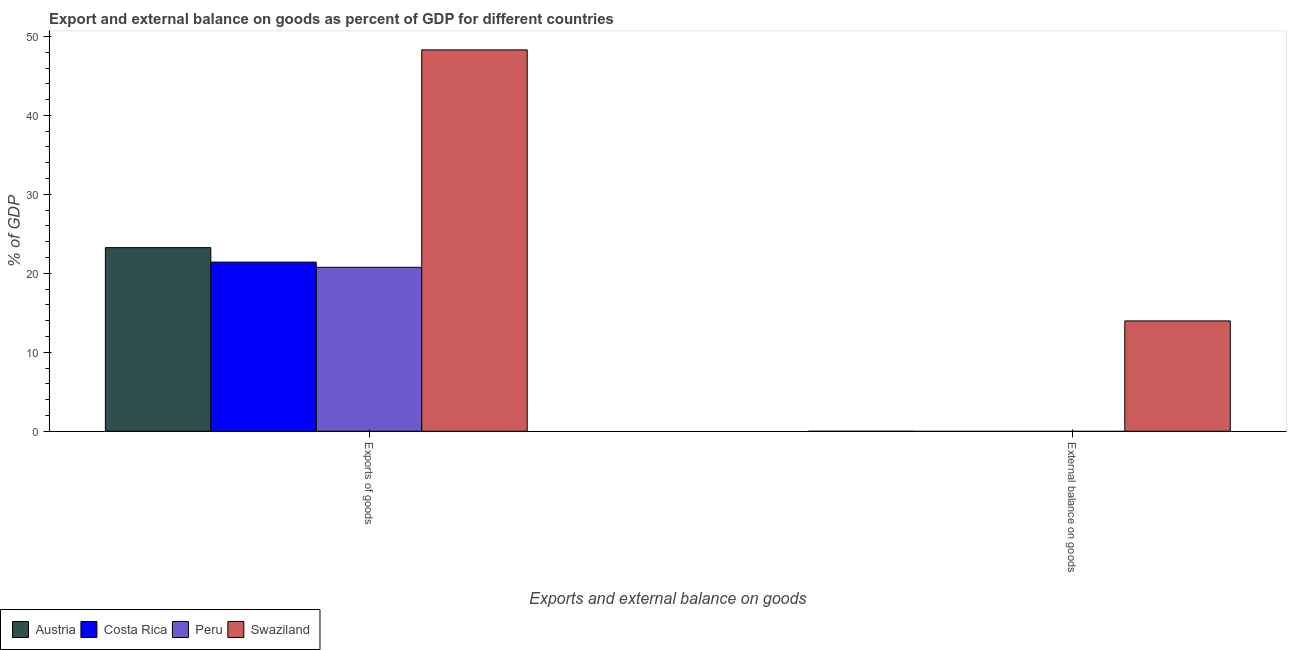Are the number of bars per tick equal to the number of legend labels?
Offer a very short reply. No. How many bars are there on the 1st tick from the right?
Your answer should be compact. 1. What is the label of the 2nd group of bars from the left?
Offer a terse response. External balance on goods. What is the export of goods as percentage of gdp in Swaziland?
Your answer should be compact. 48.29. Across all countries, what is the maximum external balance on goods as percentage of gdp?
Your answer should be compact. 13.97. Across all countries, what is the minimum export of goods as percentage of gdp?
Ensure brevity in your answer.  20.76. In which country was the export of goods as percentage of gdp maximum?
Keep it short and to the point. Swaziland. What is the total export of goods as percentage of gdp in the graph?
Ensure brevity in your answer.  113.72. What is the difference between the export of goods as percentage of gdp in Austria and that in Peru?
Offer a very short reply. 2.49. What is the difference between the export of goods as percentage of gdp in Swaziland and the external balance on goods as percentage of gdp in Austria?
Offer a very short reply. 48.29. What is the average export of goods as percentage of gdp per country?
Make the answer very short. 28.43. What is the ratio of the export of goods as percentage of gdp in Austria to that in Costa Rica?
Ensure brevity in your answer.  1.09. Are all the bars in the graph horizontal?
Offer a very short reply. No. How many countries are there in the graph?
Offer a very short reply. 4. Are the values on the major ticks of Y-axis written in scientific E-notation?
Provide a short and direct response. No. Does the graph contain any zero values?
Offer a very short reply. Yes. Where does the legend appear in the graph?
Provide a short and direct response. Bottom left. How many legend labels are there?
Make the answer very short. 4. How are the legend labels stacked?
Give a very brief answer. Horizontal. What is the title of the graph?
Your response must be concise. Export and external balance on goods as percent of GDP for different countries. What is the label or title of the X-axis?
Make the answer very short. Exports and external balance on goods. What is the label or title of the Y-axis?
Your answer should be very brief. % of GDP. What is the % of GDP in Austria in Exports of goods?
Provide a succinct answer. 23.25. What is the % of GDP in Costa Rica in Exports of goods?
Offer a very short reply. 21.42. What is the % of GDP in Peru in Exports of goods?
Offer a terse response. 20.76. What is the % of GDP of Swaziland in Exports of goods?
Your answer should be very brief. 48.29. What is the % of GDP in Costa Rica in External balance on goods?
Give a very brief answer. 0. What is the % of GDP of Peru in External balance on goods?
Your response must be concise. 0. What is the % of GDP of Swaziland in External balance on goods?
Keep it short and to the point. 13.97. Across all Exports and external balance on goods, what is the maximum % of GDP in Austria?
Offer a terse response. 23.25. Across all Exports and external balance on goods, what is the maximum % of GDP in Costa Rica?
Your response must be concise. 21.42. Across all Exports and external balance on goods, what is the maximum % of GDP of Peru?
Ensure brevity in your answer.  20.76. Across all Exports and external balance on goods, what is the maximum % of GDP in Swaziland?
Offer a terse response. 48.29. Across all Exports and external balance on goods, what is the minimum % of GDP of Austria?
Offer a terse response. 0. Across all Exports and external balance on goods, what is the minimum % of GDP of Costa Rica?
Provide a short and direct response. 0. Across all Exports and external balance on goods, what is the minimum % of GDP in Swaziland?
Provide a short and direct response. 13.97. What is the total % of GDP in Austria in the graph?
Make the answer very short. 23.25. What is the total % of GDP in Costa Rica in the graph?
Give a very brief answer. 21.42. What is the total % of GDP of Peru in the graph?
Offer a terse response. 20.76. What is the total % of GDP of Swaziland in the graph?
Your answer should be compact. 62.26. What is the difference between the % of GDP of Swaziland in Exports of goods and that in External balance on goods?
Your answer should be compact. 34.32. What is the difference between the % of GDP in Austria in Exports of goods and the % of GDP in Swaziland in External balance on goods?
Your answer should be compact. 9.28. What is the difference between the % of GDP of Costa Rica in Exports of goods and the % of GDP of Swaziland in External balance on goods?
Your answer should be compact. 7.45. What is the difference between the % of GDP in Peru in Exports of goods and the % of GDP in Swaziland in External balance on goods?
Your answer should be very brief. 6.79. What is the average % of GDP in Austria per Exports and external balance on goods?
Your answer should be compact. 11.62. What is the average % of GDP in Costa Rica per Exports and external balance on goods?
Your answer should be compact. 10.71. What is the average % of GDP of Peru per Exports and external balance on goods?
Keep it short and to the point. 10.38. What is the average % of GDP of Swaziland per Exports and external balance on goods?
Provide a short and direct response. 31.13. What is the difference between the % of GDP in Austria and % of GDP in Costa Rica in Exports of goods?
Your answer should be compact. 1.83. What is the difference between the % of GDP of Austria and % of GDP of Peru in Exports of goods?
Make the answer very short. 2.49. What is the difference between the % of GDP in Austria and % of GDP in Swaziland in Exports of goods?
Provide a succinct answer. -25.05. What is the difference between the % of GDP of Costa Rica and % of GDP of Peru in Exports of goods?
Provide a short and direct response. 0.65. What is the difference between the % of GDP in Costa Rica and % of GDP in Swaziland in Exports of goods?
Keep it short and to the point. -26.88. What is the difference between the % of GDP in Peru and % of GDP in Swaziland in Exports of goods?
Offer a terse response. -27.53. What is the ratio of the % of GDP in Swaziland in Exports of goods to that in External balance on goods?
Keep it short and to the point. 3.46. What is the difference between the highest and the second highest % of GDP of Swaziland?
Ensure brevity in your answer.  34.32. What is the difference between the highest and the lowest % of GDP in Austria?
Give a very brief answer. 23.25. What is the difference between the highest and the lowest % of GDP in Costa Rica?
Your answer should be very brief. 21.42. What is the difference between the highest and the lowest % of GDP in Peru?
Make the answer very short. 20.76. What is the difference between the highest and the lowest % of GDP in Swaziland?
Your answer should be compact. 34.32. 